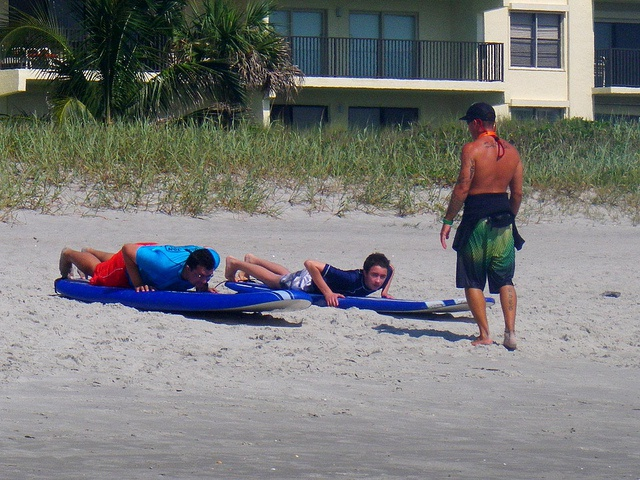Describe the objects in this image and their specific colors. I can see people in darkgreen, black, brown, maroon, and gray tones, people in darkgreen, black, navy, maroon, and lightblue tones, surfboard in darkgreen, darkblue, navy, darkgray, and black tones, people in darkgreen, black, brown, navy, and darkgray tones, and surfboard in darkgreen, darkblue, navy, gray, and darkgray tones in this image. 